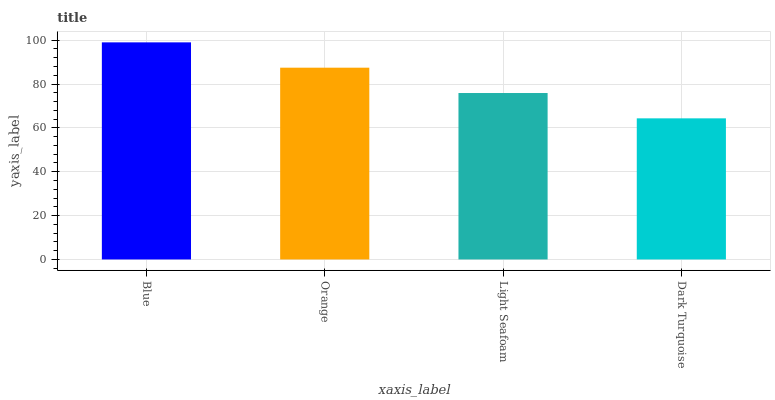Is Dark Turquoise the minimum?
Answer yes or no. Yes. Is Blue the maximum?
Answer yes or no. Yes. Is Orange the minimum?
Answer yes or no. No. Is Orange the maximum?
Answer yes or no. No. Is Blue greater than Orange?
Answer yes or no. Yes. Is Orange less than Blue?
Answer yes or no. Yes. Is Orange greater than Blue?
Answer yes or no. No. Is Blue less than Orange?
Answer yes or no. No. Is Orange the high median?
Answer yes or no. Yes. Is Light Seafoam the low median?
Answer yes or no. Yes. Is Light Seafoam the high median?
Answer yes or no. No. Is Orange the low median?
Answer yes or no. No. 